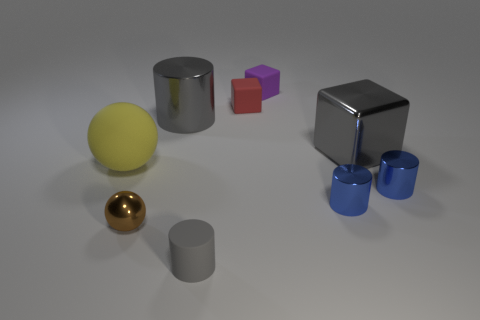Add 1 red cubes. How many objects exist? 10 Subtract all small matte blocks. How many blocks are left? 1 Subtract all brown balls. How many balls are left? 1 Subtract 3 blocks. How many blocks are left? 0 Subtract all red spheres. Subtract all purple blocks. How many spheres are left? 2 Subtract all purple blocks. How many brown balls are left? 1 Subtract all big rubber objects. Subtract all gray cylinders. How many objects are left? 6 Add 4 small red matte cubes. How many small red matte cubes are left? 5 Add 1 purple objects. How many purple objects exist? 2 Subtract 1 yellow balls. How many objects are left? 8 